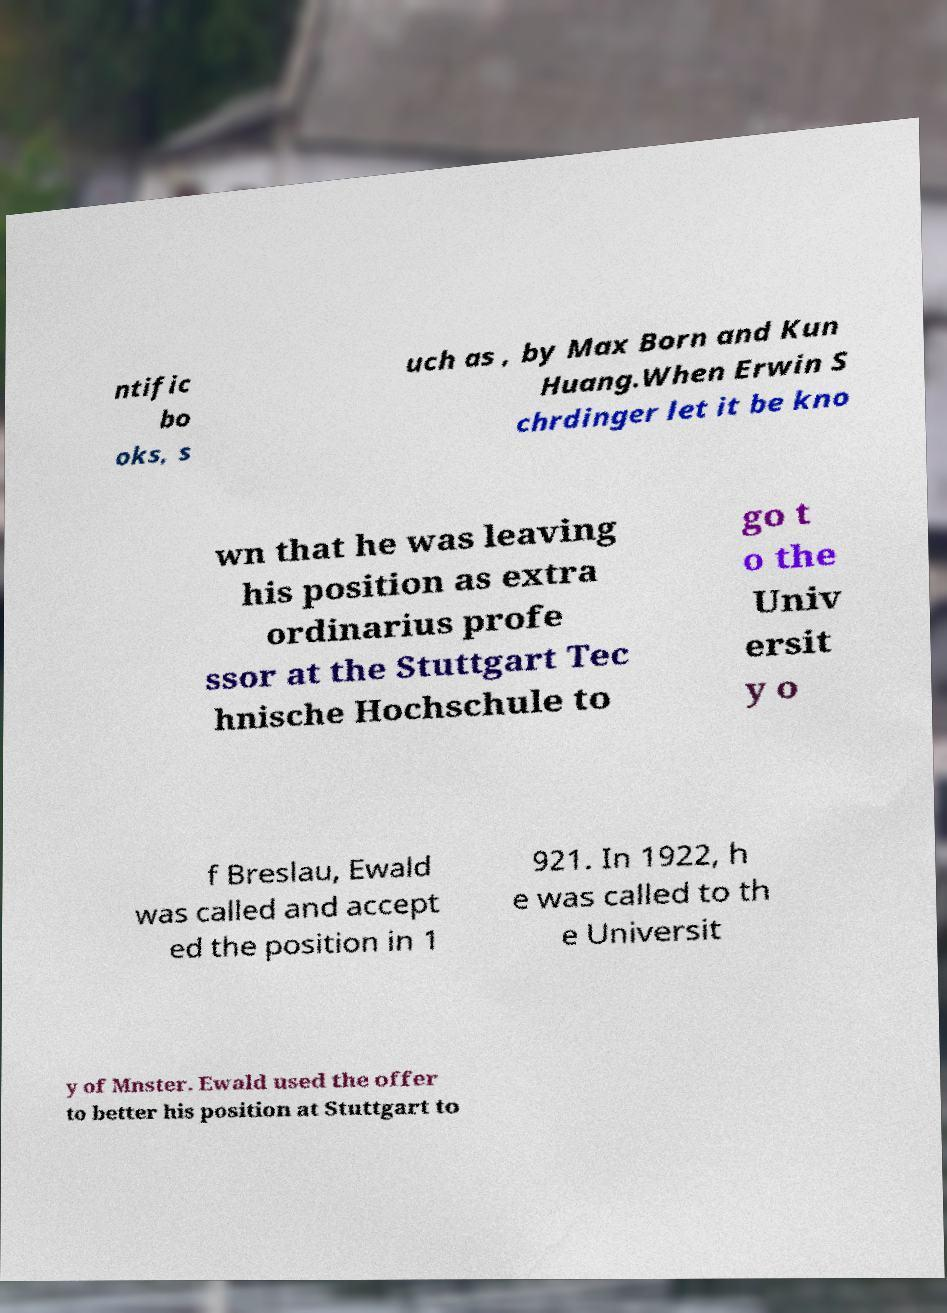Please read and relay the text visible in this image. What does it say? ntific bo oks, s uch as , by Max Born and Kun Huang.When Erwin S chrdinger let it be kno wn that he was leaving his position as extra ordinarius profe ssor at the Stuttgart Tec hnische Hochschule to go t o the Univ ersit y o f Breslau, Ewald was called and accept ed the position in 1 921. In 1922, h e was called to th e Universit y of Mnster. Ewald used the offer to better his position at Stuttgart to 